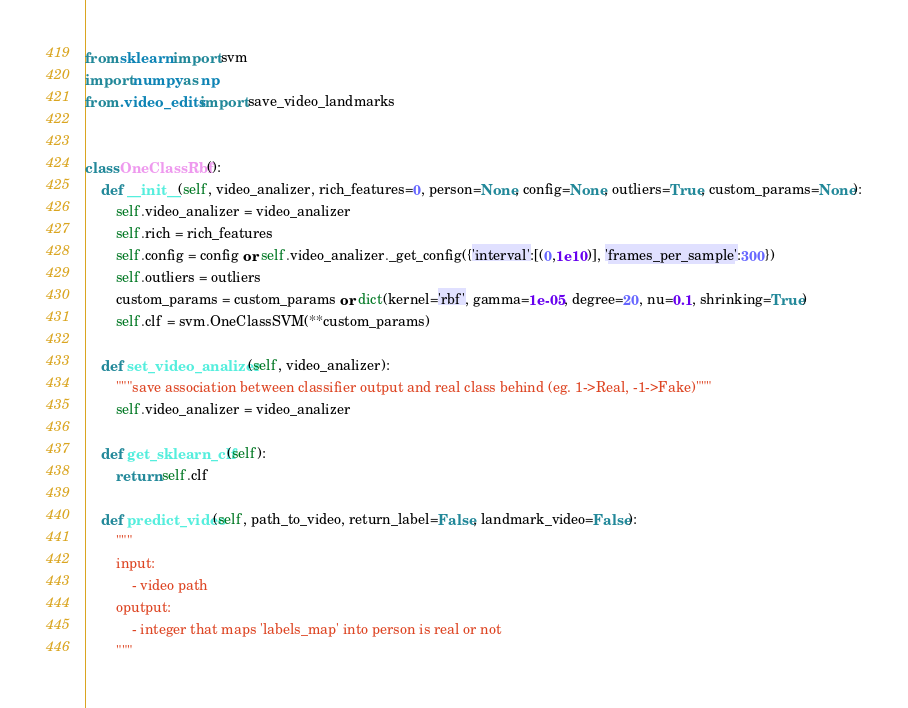Convert code to text. <code><loc_0><loc_0><loc_500><loc_500><_Python_>from sklearn import svm
import numpy as np
from .video_edits import save_video_landmarks


class OneClassRbf():
    def __init__(self, video_analizer, rich_features=0, person=None, config=None, outliers=True, custom_params=None):
        self.video_analizer = video_analizer
        self.rich = rich_features
        self.config = config or self.video_analizer._get_config({'interval':[(0,1e10)], 'frames_per_sample':300})
        self.outliers = outliers
        custom_params = custom_params or dict(kernel='rbf', gamma=1e-05, degree=20, nu=0.1, shrinking=True)
        self.clf = svm.OneClassSVM(**custom_params)

    def set_video_analizer(self, video_analizer):
        """save association between classifier output and real class behind (eg. 1->Real, -1->Fake)"""
        self.video_analizer = video_analizer

    def get_sklearn_clf(self):
        return self.clf

    def predict_video(self, path_to_video, return_label=False, landmark_video=False):
        """
        input:
            - video path
        oputput:
            - integer that maps 'labels_map' into person is real or not
        """</code> 